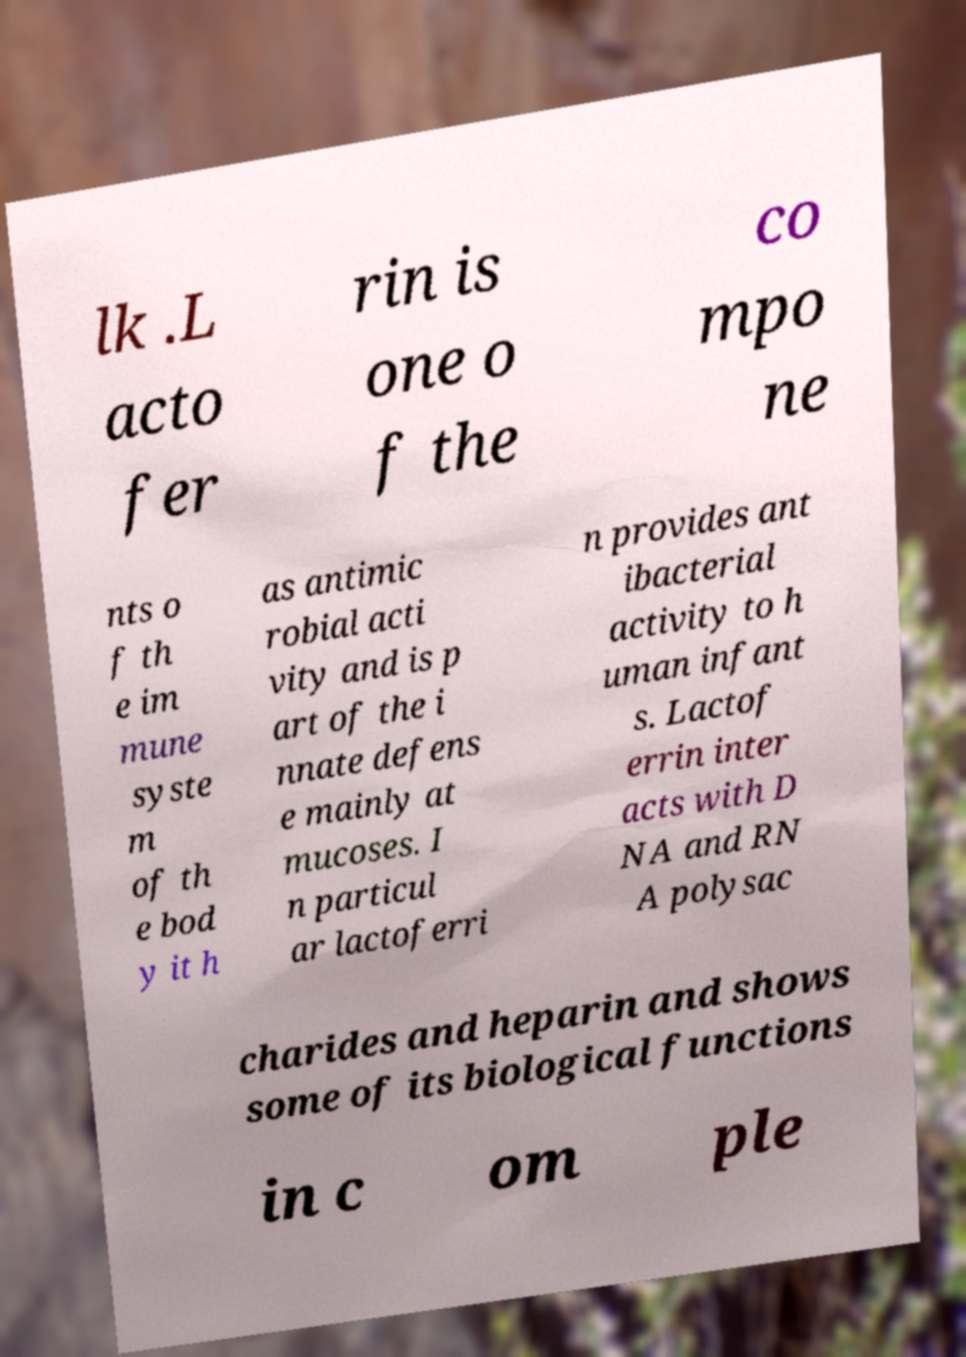There's text embedded in this image that I need extracted. Can you transcribe it verbatim? lk .L acto fer rin is one o f the co mpo ne nts o f th e im mune syste m of th e bod y it h as antimic robial acti vity and is p art of the i nnate defens e mainly at mucoses. I n particul ar lactoferri n provides ant ibacterial activity to h uman infant s. Lactof errin inter acts with D NA and RN A polysac charides and heparin and shows some of its biological functions in c om ple 